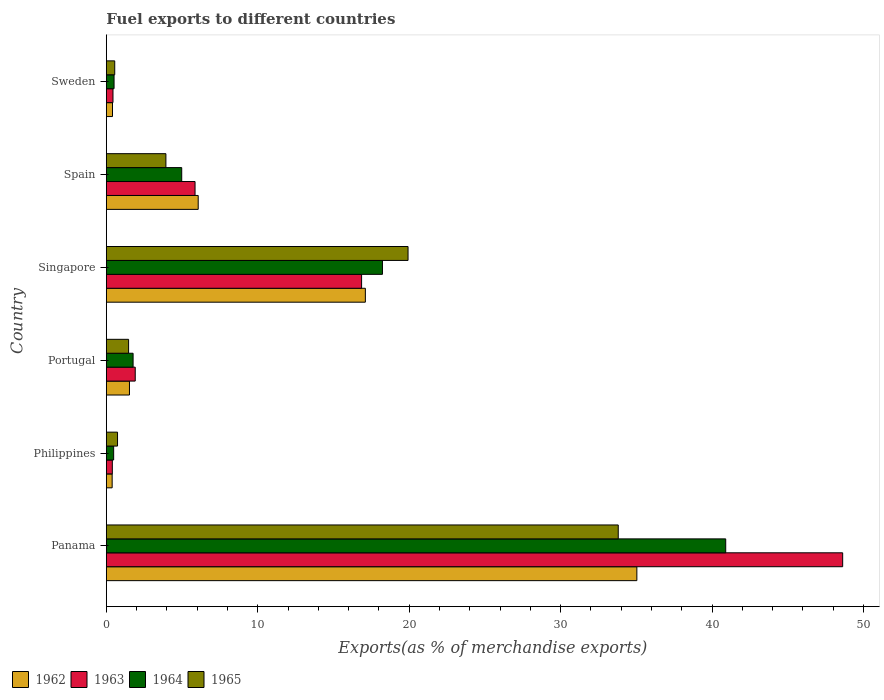Are the number of bars on each tick of the Y-axis equal?
Your response must be concise. Yes. How many bars are there on the 6th tick from the bottom?
Give a very brief answer. 4. What is the label of the 2nd group of bars from the top?
Provide a succinct answer. Spain. In how many cases, is the number of bars for a given country not equal to the number of legend labels?
Give a very brief answer. 0. What is the percentage of exports to different countries in 1965 in Philippines?
Give a very brief answer. 0.74. Across all countries, what is the maximum percentage of exports to different countries in 1965?
Ensure brevity in your answer.  33.8. Across all countries, what is the minimum percentage of exports to different countries in 1963?
Keep it short and to the point. 0.4. In which country was the percentage of exports to different countries in 1962 maximum?
Give a very brief answer. Panama. In which country was the percentage of exports to different countries in 1964 minimum?
Give a very brief answer. Philippines. What is the total percentage of exports to different countries in 1965 in the graph?
Provide a succinct answer. 60.42. What is the difference between the percentage of exports to different countries in 1962 in Spain and that in Sweden?
Your response must be concise. 5.66. What is the difference between the percentage of exports to different countries in 1965 in Portugal and the percentage of exports to different countries in 1964 in Spain?
Give a very brief answer. -3.51. What is the average percentage of exports to different countries in 1963 per country?
Ensure brevity in your answer.  12.35. What is the difference between the percentage of exports to different countries in 1965 and percentage of exports to different countries in 1963 in Sweden?
Provide a succinct answer. 0.12. What is the ratio of the percentage of exports to different countries in 1964 in Panama to that in Sweden?
Your response must be concise. 80.13. Is the percentage of exports to different countries in 1963 in Singapore less than that in Spain?
Your response must be concise. No. Is the difference between the percentage of exports to different countries in 1965 in Philippines and Singapore greater than the difference between the percentage of exports to different countries in 1963 in Philippines and Singapore?
Provide a succinct answer. No. What is the difference between the highest and the second highest percentage of exports to different countries in 1965?
Offer a very short reply. 13.88. What is the difference between the highest and the lowest percentage of exports to different countries in 1965?
Your answer should be very brief. 33.25. In how many countries, is the percentage of exports to different countries in 1963 greater than the average percentage of exports to different countries in 1963 taken over all countries?
Give a very brief answer. 2. Is it the case that in every country, the sum of the percentage of exports to different countries in 1964 and percentage of exports to different countries in 1963 is greater than the sum of percentage of exports to different countries in 1962 and percentage of exports to different countries in 1965?
Provide a short and direct response. No. What does the 4th bar from the bottom in Philippines represents?
Your response must be concise. 1965. How many countries are there in the graph?
Make the answer very short. 6. Are the values on the major ticks of X-axis written in scientific E-notation?
Give a very brief answer. No. Does the graph contain any zero values?
Ensure brevity in your answer.  No. Does the graph contain grids?
Make the answer very short. No. How many legend labels are there?
Give a very brief answer. 4. What is the title of the graph?
Offer a very short reply. Fuel exports to different countries. Does "2006" appear as one of the legend labels in the graph?
Keep it short and to the point. No. What is the label or title of the X-axis?
Make the answer very short. Exports(as % of merchandise exports). What is the label or title of the Y-axis?
Provide a short and direct response. Country. What is the Exports(as % of merchandise exports) of 1962 in Panama?
Your response must be concise. 35.03. What is the Exports(as % of merchandise exports) in 1963 in Panama?
Provide a succinct answer. 48.62. What is the Exports(as % of merchandise exports) in 1964 in Panama?
Make the answer very short. 40.9. What is the Exports(as % of merchandise exports) in 1965 in Panama?
Keep it short and to the point. 33.8. What is the Exports(as % of merchandise exports) in 1962 in Philippines?
Provide a succinct answer. 0.38. What is the Exports(as % of merchandise exports) in 1963 in Philippines?
Make the answer very short. 0.4. What is the Exports(as % of merchandise exports) in 1964 in Philippines?
Keep it short and to the point. 0.48. What is the Exports(as % of merchandise exports) of 1965 in Philippines?
Keep it short and to the point. 0.74. What is the Exports(as % of merchandise exports) of 1962 in Portugal?
Give a very brief answer. 1.53. What is the Exports(as % of merchandise exports) of 1963 in Portugal?
Your answer should be very brief. 1.91. What is the Exports(as % of merchandise exports) of 1964 in Portugal?
Keep it short and to the point. 1.77. What is the Exports(as % of merchandise exports) of 1965 in Portugal?
Ensure brevity in your answer.  1.47. What is the Exports(as % of merchandise exports) of 1962 in Singapore?
Offer a very short reply. 17.1. What is the Exports(as % of merchandise exports) of 1963 in Singapore?
Provide a succinct answer. 16.85. What is the Exports(as % of merchandise exports) in 1964 in Singapore?
Offer a terse response. 18.23. What is the Exports(as % of merchandise exports) in 1965 in Singapore?
Your response must be concise. 19.92. What is the Exports(as % of merchandise exports) of 1962 in Spain?
Provide a succinct answer. 6.07. What is the Exports(as % of merchandise exports) of 1963 in Spain?
Provide a short and direct response. 5.86. What is the Exports(as % of merchandise exports) of 1964 in Spain?
Make the answer very short. 4.98. What is the Exports(as % of merchandise exports) in 1965 in Spain?
Provide a succinct answer. 3.93. What is the Exports(as % of merchandise exports) of 1962 in Sweden?
Ensure brevity in your answer.  0.41. What is the Exports(as % of merchandise exports) in 1963 in Sweden?
Offer a terse response. 0.44. What is the Exports(as % of merchandise exports) of 1964 in Sweden?
Your answer should be very brief. 0.51. What is the Exports(as % of merchandise exports) in 1965 in Sweden?
Your answer should be very brief. 0.55. Across all countries, what is the maximum Exports(as % of merchandise exports) of 1962?
Your answer should be compact. 35.03. Across all countries, what is the maximum Exports(as % of merchandise exports) of 1963?
Provide a succinct answer. 48.62. Across all countries, what is the maximum Exports(as % of merchandise exports) of 1964?
Give a very brief answer. 40.9. Across all countries, what is the maximum Exports(as % of merchandise exports) in 1965?
Your answer should be very brief. 33.8. Across all countries, what is the minimum Exports(as % of merchandise exports) of 1962?
Keep it short and to the point. 0.38. Across all countries, what is the minimum Exports(as % of merchandise exports) in 1963?
Make the answer very short. 0.4. Across all countries, what is the minimum Exports(as % of merchandise exports) in 1964?
Make the answer very short. 0.48. Across all countries, what is the minimum Exports(as % of merchandise exports) of 1965?
Provide a short and direct response. 0.55. What is the total Exports(as % of merchandise exports) of 1962 in the graph?
Make the answer very short. 60.52. What is the total Exports(as % of merchandise exports) in 1963 in the graph?
Ensure brevity in your answer.  74.08. What is the total Exports(as % of merchandise exports) in 1964 in the graph?
Keep it short and to the point. 66.87. What is the total Exports(as % of merchandise exports) of 1965 in the graph?
Your answer should be compact. 60.42. What is the difference between the Exports(as % of merchandise exports) in 1962 in Panama and that in Philippines?
Offer a very short reply. 34.65. What is the difference between the Exports(as % of merchandise exports) of 1963 in Panama and that in Philippines?
Provide a short and direct response. 48.22. What is the difference between the Exports(as % of merchandise exports) of 1964 in Panama and that in Philippines?
Give a very brief answer. 40.41. What is the difference between the Exports(as % of merchandise exports) in 1965 in Panama and that in Philippines?
Offer a very short reply. 33.06. What is the difference between the Exports(as % of merchandise exports) in 1962 in Panama and that in Portugal?
Your answer should be very brief. 33.5. What is the difference between the Exports(as % of merchandise exports) of 1963 in Panama and that in Portugal?
Make the answer very short. 46.71. What is the difference between the Exports(as % of merchandise exports) of 1964 in Panama and that in Portugal?
Your answer should be compact. 39.13. What is the difference between the Exports(as % of merchandise exports) of 1965 in Panama and that in Portugal?
Provide a succinct answer. 32.33. What is the difference between the Exports(as % of merchandise exports) of 1962 in Panama and that in Singapore?
Make the answer very short. 17.93. What is the difference between the Exports(as % of merchandise exports) of 1963 in Panama and that in Singapore?
Give a very brief answer. 31.77. What is the difference between the Exports(as % of merchandise exports) of 1964 in Panama and that in Singapore?
Your answer should be very brief. 22.67. What is the difference between the Exports(as % of merchandise exports) in 1965 in Panama and that in Singapore?
Make the answer very short. 13.88. What is the difference between the Exports(as % of merchandise exports) in 1962 in Panama and that in Spain?
Your response must be concise. 28.96. What is the difference between the Exports(as % of merchandise exports) in 1963 in Panama and that in Spain?
Offer a terse response. 42.76. What is the difference between the Exports(as % of merchandise exports) in 1964 in Panama and that in Spain?
Give a very brief answer. 35.92. What is the difference between the Exports(as % of merchandise exports) in 1965 in Panama and that in Spain?
Your answer should be compact. 29.87. What is the difference between the Exports(as % of merchandise exports) in 1962 in Panama and that in Sweden?
Offer a terse response. 34.62. What is the difference between the Exports(as % of merchandise exports) in 1963 in Panama and that in Sweden?
Your answer should be very brief. 48.18. What is the difference between the Exports(as % of merchandise exports) of 1964 in Panama and that in Sweden?
Keep it short and to the point. 40.39. What is the difference between the Exports(as % of merchandise exports) of 1965 in Panama and that in Sweden?
Provide a short and direct response. 33.25. What is the difference between the Exports(as % of merchandise exports) of 1962 in Philippines and that in Portugal?
Make the answer very short. -1.14. What is the difference between the Exports(as % of merchandise exports) in 1963 in Philippines and that in Portugal?
Your answer should be compact. -1.51. What is the difference between the Exports(as % of merchandise exports) in 1964 in Philippines and that in Portugal?
Provide a succinct answer. -1.28. What is the difference between the Exports(as % of merchandise exports) in 1965 in Philippines and that in Portugal?
Your answer should be very brief. -0.73. What is the difference between the Exports(as % of merchandise exports) in 1962 in Philippines and that in Singapore?
Give a very brief answer. -16.72. What is the difference between the Exports(as % of merchandise exports) of 1963 in Philippines and that in Singapore?
Your answer should be compact. -16.46. What is the difference between the Exports(as % of merchandise exports) of 1964 in Philippines and that in Singapore?
Ensure brevity in your answer.  -17.75. What is the difference between the Exports(as % of merchandise exports) in 1965 in Philippines and that in Singapore?
Offer a very short reply. -19.18. What is the difference between the Exports(as % of merchandise exports) in 1962 in Philippines and that in Spain?
Your response must be concise. -5.68. What is the difference between the Exports(as % of merchandise exports) of 1963 in Philippines and that in Spain?
Offer a terse response. -5.46. What is the difference between the Exports(as % of merchandise exports) of 1964 in Philippines and that in Spain?
Your answer should be compact. -4.49. What is the difference between the Exports(as % of merchandise exports) of 1965 in Philippines and that in Spain?
Your response must be concise. -3.19. What is the difference between the Exports(as % of merchandise exports) of 1962 in Philippines and that in Sweden?
Make the answer very short. -0.02. What is the difference between the Exports(as % of merchandise exports) of 1963 in Philippines and that in Sweden?
Offer a very short reply. -0.04. What is the difference between the Exports(as % of merchandise exports) of 1964 in Philippines and that in Sweden?
Keep it short and to the point. -0.03. What is the difference between the Exports(as % of merchandise exports) of 1965 in Philippines and that in Sweden?
Offer a very short reply. 0.19. What is the difference between the Exports(as % of merchandise exports) in 1962 in Portugal and that in Singapore?
Give a very brief answer. -15.58. What is the difference between the Exports(as % of merchandise exports) of 1963 in Portugal and that in Singapore?
Provide a short and direct response. -14.95. What is the difference between the Exports(as % of merchandise exports) in 1964 in Portugal and that in Singapore?
Offer a terse response. -16.47. What is the difference between the Exports(as % of merchandise exports) of 1965 in Portugal and that in Singapore?
Your answer should be very brief. -18.45. What is the difference between the Exports(as % of merchandise exports) of 1962 in Portugal and that in Spain?
Give a very brief answer. -4.54. What is the difference between the Exports(as % of merchandise exports) in 1963 in Portugal and that in Spain?
Offer a very short reply. -3.95. What is the difference between the Exports(as % of merchandise exports) of 1964 in Portugal and that in Spain?
Offer a very short reply. -3.21. What is the difference between the Exports(as % of merchandise exports) of 1965 in Portugal and that in Spain?
Your answer should be compact. -2.46. What is the difference between the Exports(as % of merchandise exports) in 1962 in Portugal and that in Sweden?
Provide a succinct answer. 1.12. What is the difference between the Exports(as % of merchandise exports) in 1963 in Portugal and that in Sweden?
Ensure brevity in your answer.  1.47. What is the difference between the Exports(as % of merchandise exports) in 1964 in Portugal and that in Sweden?
Offer a very short reply. 1.26. What is the difference between the Exports(as % of merchandise exports) in 1965 in Portugal and that in Sweden?
Give a very brief answer. 0.91. What is the difference between the Exports(as % of merchandise exports) of 1962 in Singapore and that in Spain?
Provide a short and direct response. 11.04. What is the difference between the Exports(as % of merchandise exports) in 1963 in Singapore and that in Spain?
Your response must be concise. 11. What is the difference between the Exports(as % of merchandise exports) in 1964 in Singapore and that in Spain?
Offer a very short reply. 13.25. What is the difference between the Exports(as % of merchandise exports) of 1965 in Singapore and that in Spain?
Offer a very short reply. 15.99. What is the difference between the Exports(as % of merchandise exports) in 1962 in Singapore and that in Sweden?
Give a very brief answer. 16.7. What is the difference between the Exports(as % of merchandise exports) in 1963 in Singapore and that in Sweden?
Provide a short and direct response. 16.42. What is the difference between the Exports(as % of merchandise exports) in 1964 in Singapore and that in Sweden?
Offer a terse response. 17.72. What is the difference between the Exports(as % of merchandise exports) in 1965 in Singapore and that in Sweden?
Keep it short and to the point. 19.37. What is the difference between the Exports(as % of merchandise exports) in 1962 in Spain and that in Sweden?
Ensure brevity in your answer.  5.66. What is the difference between the Exports(as % of merchandise exports) in 1963 in Spain and that in Sweden?
Provide a short and direct response. 5.42. What is the difference between the Exports(as % of merchandise exports) in 1964 in Spain and that in Sweden?
Provide a short and direct response. 4.47. What is the difference between the Exports(as % of merchandise exports) of 1965 in Spain and that in Sweden?
Make the answer very short. 3.38. What is the difference between the Exports(as % of merchandise exports) of 1962 in Panama and the Exports(as % of merchandise exports) of 1963 in Philippines?
Offer a terse response. 34.63. What is the difference between the Exports(as % of merchandise exports) of 1962 in Panama and the Exports(as % of merchandise exports) of 1964 in Philippines?
Your answer should be very brief. 34.55. What is the difference between the Exports(as % of merchandise exports) in 1962 in Panama and the Exports(as % of merchandise exports) in 1965 in Philippines?
Give a very brief answer. 34.29. What is the difference between the Exports(as % of merchandise exports) in 1963 in Panama and the Exports(as % of merchandise exports) in 1964 in Philippines?
Your response must be concise. 48.14. What is the difference between the Exports(as % of merchandise exports) in 1963 in Panama and the Exports(as % of merchandise exports) in 1965 in Philippines?
Provide a succinct answer. 47.88. What is the difference between the Exports(as % of merchandise exports) of 1964 in Panama and the Exports(as % of merchandise exports) of 1965 in Philippines?
Your answer should be compact. 40.16. What is the difference between the Exports(as % of merchandise exports) of 1962 in Panama and the Exports(as % of merchandise exports) of 1963 in Portugal?
Your answer should be very brief. 33.12. What is the difference between the Exports(as % of merchandise exports) in 1962 in Panama and the Exports(as % of merchandise exports) in 1964 in Portugal?
Your response must be concise. 33.26. What is the difference between the Exports(as % of merchandise exports) in 1962 in Panama and the Exports(as % of merchandise exports) in 1965 in Portugal?
Make the answer very short. 33.56. What is the difference between the Exports(as % of merchandise exports) in 1963 in Panama and the Exports(as % of merchandise exports) in 1964 in Portugal?
Your answer should be compact. 46.85. What is the difference between the Exports(as % of merchandise exports) of 1963 in Panama and the Exports(as % of merchandise exports) of 1965 in Portugal?
Give a very brief answer. 47.15. What is the difference between the Exports(as % of merchandise exports) of 1964 in Panama and the Exports(as % of merchandise exports) of 1965 in Portugal?
Your answer should be compact. 39.43. What is the difference between the Exports(as % of merchandise exports) of 1962 in Panama and the Exports(as % of merchandise exports) of 1963 in Singapore?
Make the answer very short. 18.18. What is the difference between the Exports(as % of merchandise exports) in 1962 in Panama and the Exports(as % of merchandise exports) in 1964 in Singapore?
Provide a short and direct response. 16.8. What is the difference between the Exports(as % of merchandise exports) of 1962 in Panama and the Exports(as % of merchandise exports) of 1965 in Singapore?
Your response must be concise. 15.11. What is the difference between the Exports(as % of merchandise exports) of 1963 in Panama and the Exports(as % of merchandise exports) of 1964 in Singapore?
Your answer should be compact. 30.39. What is the difference between the Exports(as % of merchandise exports) of 1963 in Panama and the Exports(as % of merchandise exports) of 1965 in Singapore?
Provide a succinct answer. 28.7. What is the difference between the Exports(as % of merchandise exports) of 1964 in Panama and the Exports(as % of merchandise exports) of 1965 in Singapore?
Provide a short and direct response. 20.98. What is the difference between the Exports(as % of merchandise exports) of 1962 in Panama and the Exports(as % of merchandise exports) of 1963 in Spain?
Keep it short and to the point. 29.17. What is the difference between the Exports(as % of merchandise exports) of 1962 in Panama and the Exports(as % of merchandise exports) of 1964 in Spain?
Your response must be concise. 30.05. What is the difference between the Exports(as % of merchandise exports) in 1962 in Panama and the Exports(as % of merchandise exports) in 1965 in Spain?
Ensure brevity in your answer.  31.1. What is the difference between the Exports(as % of merchandise exports) in 1963 in Panama and the Exports(as % of merchandise exports) in 1964 in Spain?
Make the answer very short. 43.64. What is the difference between the Exports(as % of merchandise exports) of 1963 in Panama and the Exports(as % of merchandise exports) of 1965 in Spain?
Keep it short and to the point. 44.69. What is the difference between the Exports(as % of merchandise exports) of 1964 in Panama and the Exports(as % of merchandise exports) of 1965 in Spain?
Keep it short and to the point. 36.96. What is the difference between the Exports(as % of merchandise exports) of 1962 in Panama and the Exports(as % of merchandise exports) of 1963 in Sweden?
Offer a terse response. 34.59. What is the difference between the Exports(as % of merchandise exports) in 1962 in Panama and the Exports(as % of merchandise exports) in 1964 in Sweden?
Make the answer very short. 34.52. What is the difference between the Exports(as % of merchandise exports) in 1962 in Panama and the Exports(as % of merchandise exports) in 1965 in Sweden?
Your answer should be very brief. 34.48. What is the difference between the Exports(as % of merchandise exports) in 1963 in Panama and the Exports(as % of merchandise exports) in 1964 in Sweden?
Provide a short and direct response. 48.11. What is the difference between the Exports(as % of merchandise exports) in 1963 in Panama and the Exports(as % of merchandise exports) in 1965 in Sweden?
Your response must be concise. 48.07. What is the difference between the Exports(as % of merchandise exports) of 1964 in Panama and the Exports(as % of merchandise exports) of 1965 in Sweden?
Your answer should be very brief. 40.34. What is the difference between the Exports(as % of merchandise exports) of 1962 in Philippines and the Exports(as % of merchandise exports) of 1963 in Portugal?
Your response must be concise. -1.52. What is the difference between the Exports(as % of merchandise exports) in 1962 in Philippines and the Exports(as % of merchandise exports) in 1964 in Portugal?
Your answer should be very brief. -1.38. What is the difference between the Exports(as % of merchandise exports) of 1962 in Philippines and the Exports(as % of merchandise exports) of 1965 in Portugal?
Offer a very short reply. -1.08. What is the difference between the Exports(as % of merchandise exports) of 1963 in Philippines and the Exports(as % of merchandise exports) of 1964 in Portugal?
Ensure brevity in your answer.  -1.37. What is the difference between the Exports(as % of merchandise exports) of 1963 in Philippines and the Exports(as % of merchandise exports) of 1965 in Portugal?
Keep it short and to the point. -1.07. What is the difference between the Exports(as % of merchandise exports) of 1964 in Philippines and the Exports(as % of merchandise exports) of 1965 in Portugal?
Give a very brief answer. -0.99. What is the difference between the Exports(as % of merchandise exports) of 1962 in Philippines and the Exports(as % of merchandise exports) of 1963 in Singapore?
Your answer should be compact. -16.47. What is the difference between the Exports(as % of merchandise exports) in 1962 in Philippines and the Exports(as % of merchandise exports) in 1964 in Singapore?
Make the answer very short. -17.85. What is the difference between the Exports(as % of merchandise exports) of 1962 in Philippines and the Exports(as % of merchandise exports) of 1965 in Singapore?
Provide a succinct answer. -19.54. What is the difference between the Exports(as % of merchandise exports) in 1963 in Philippines and the Exports(as % of merchandise exports) in 1964 in Singapore?
Make the answer very short. -17.84. What is the difference between the Exports(as % of merchandise exports) in 1963 in Philippines and the Exports(as % of merchandise exports) in 1965 in Singapore?
Your answer should be very brief. -19.53. What is the difference between the Exports(as % of merchandise exports) of 1964 in Philippines and the Exports(as % of merchandise exports) of 1965 in Singapore?
Ensure brevity in your answer.  -19.44. What is the difference between the Exports(as % of merchandise exports) of 1962 in Philippines and the Exports(as % of merchandise exports) of 1963 in Spain?
Give a very brief answer. -5.47. What is the difference between the Exports(as % of merchandise exports) in 1962 in Philippines and the Exports(as % of merchandise exports) in 1964 in Spain?
Make the answer very short. -4.59. What is the difference between the Exports(as % of merchandise exports) in 1962 in Philippines and the Exports(as % of merchandise exports) in 1965 in Spain?
Provide a succinct answer. -3.55. What is the difference between the Exports(as % of merchandise exports) in 1963 in Philippines and the Exports(as % of merchandise exports) in 1964 in Spain?
Your answer should be compact. -4.58. What is the difference between the Exports(as % of merchandise exports) of 1963 in Philippines and the Exports(as % of merchandise exports) of 1965 in Spain?
Make the answer very short. -3.54. What is the difference between the Exports(as % of merchandise exports) of 1964 in Philippines and the Exports(as % of merchandise exports) of 1965 in Spain?
Provide a short and direct response. -3.45. What is the difference between the Exports(as % of merchandise exports) in 1962 in Philippines and the Exports(as % of merchandise exports) in 1963 in Sweden?
Offer a very short reply. -0.05. What is the difference between the Exports(as % of merchandise exports) of 1962 in Philippines and the Exports(as % of merchandise exports) of 1964 in Sweden?
Offer a very short reply. -0.13. What is the difference between the Exports(as % of merchandise exports) in 1962 in Philippines and the Exports(as % of merchandise exports) in 1965 in Sweden?
Your answer should be very brief. -0.17. What is the difference between the Exports(as % of merchandise exports) in 1963 in Philippines and the Exports(as % of merchandise exports) in 1964 in Sweden?
Offer a very short reply. -0.11. What is the difference between the Exports(as % of merchandise exports) in 1963 in Philippines and the Exports(as % of merchandise exports) in 1965 in Sweden?
Keep it short and to the point. -0.16. What is the difference between the Exports(as % of merchandise exports) of 1964 in Philippines and the Exports(as % of merchandise exports) of 1965 in Sweden?
Offer a very short reply. -0.07. What is the difference between the Exports(as % of merchandise exports) of 1962 in Portugal and the Exports(as % of merchandise exports) of 1963 in Singapore?
Provide a short and direct response. -15.33. What is the difference between the Exports(as % of merchandise exports) in 1962 in Portugal and the Exports(as % of merchandise exports) in 1964 in Singapore?
Provide a succinct answer. -16.7. What is the difference between the Exports(as % of merchandise exports) in 1962 in Portugal and the Exports(as % of merchandise exports) in 1965 in Singapore?
Your answer should be very brief. -18.39. What is the difference between the Exports(as % of merchandise exports) of 1963 in Portugal and the Exports(as % of merchandise exports) of 1964 in Singapore?
Offer a very short reply. -16.32. What is the difference between the Exports(as % of merchandise exports) in 1963 in Portugal and the Exports(as % of merchandise exports) in 1965 in Singapore?
Provide a succinct answer. -18.01. What is the difference between the Exports(as % of merchandise exports) in 1964 in Portugal and the Exports(as % of merchandise exports) in 1965 in Singapore?
Give a very brief answer. -18.16. What is the difference between the Exports(as % of merchandise exports) of 1962 in Portugal and the Exports(as % of merchandise exports) of 1963 in Spain?
Your response must be concise. -4.33. What is the difference between the Exports(as % of merchandise exports) of 1962 in Portugal and the Exports(as % of merchandise exports) of 1964 in Spain?
Provide a succinct answer. -3.45. What is the difference between the Exports(as % of merchandise exports) of 1962 in Portugal and the Exports(as % of merchandise exports) of 1965 in Spain?
Offer a terse response. -2.41. What is the difference between the Exports(as % of merchandise exports) in 1963 in Portugal and the Exports(as % of merchandise exports) in 1964 in Spain?
Your answer should be very brief. -3.07. What is the difference between the Exports(as % of merchandise exports) of 1963 in Portugal and the Exports(as % of merchandise exports) of 1965 in Spain?
Your response must be concise. -2.03. What is the difference between the Exports(as % of merchandise exports) of 1964 in Portugal and the Exports(as % of merchandise exports) of 1965 in Spain?
Offer a terse response. -2.17. What is the difference between the Exports(as % of merchandise exports) of 1962 in Portugal and the Exports(as % of merchandise exports) of 1963 in Sweden?
Make the answer very short. 1.09. What is the difference between the Exports(as % of merchandise exports) in 1962 in Portugal and the Exports(as % of merchandise exports) in 1964 in Sweden?
Your answer should be very brief. 1.02. What is the difference between the Exports(as % of merchandise exports) of 1962 in Portugal and the Exports(as % of merchandise exports) of 1965 in Sweden?
Provide a short and direct response. 0.97. What is the difference between the Exports(as % of merchandise exports) in 1963 in Portugal and the Exports(as % of merchandise exports) in 1964 in Sweden?
Give a very brief answer. 1.4. What is the difference between the Exports(as % of merchandise exports) of 1963 in Portugal and the Exports(as % of merchandise exports) of 1965 in Sweden?
Ensure brevity in your answer.  1.35. What is the difference between the Exports(as % of merchandise exports) in 1964 in Portugal and the Exports(as % of merchandise exports) in 1965 in Sweden?
Provide a succinct answer. 1.21. What is the difference between the Exports(as % of merchandise exports) of 1962 in Singapore and the Exports(as % of merchandise exports) of 1963 in Spain?
Provide a succinct answer. 11.25. What is the difference between the Exports(as % of merchandise exports) of 1962 in Singapore and the Exports(as % of merchandise exports) of 1964 in Spain?
Your answer should be compact. 12.13. What is the difference between the Exports(as % of merchandise exports) of 1962 in Singapore and the Exports(as % of merchandise exports) of 1965 in Spain?
Provide a short and direct response. 13.17. What is the difference between the Exports(as % of merchandise exports) in 1963 in Singapore and the Exports(as % of merchandise exports) in 1964 in Spain?
Provide a short and direct response. 11.88. What is the difference between the Exports(as % of merchandise exports) in 1963 in Singapore and the Exports(as % of merchandise exports) in 1965 in Spain?
Make the answer very short. 12.92. What is the difference between the Exports(as % of merchandise exports) in 1964 in Singapore and the Exports(as % of merchandise exports) in 1965 in Spain?
Your answer should be very brief. 14.3. What is the difference between the Exports(as % of merchandise exports) of 1962 in Singapore and the Exports(as % of merchandise exports) of 1963 in Sweden?
Keep it short and to the point. 16.66. What is the difference between the Exports(as % of merchandise exports) of 1962 in Singapore and the Exports(as % of merchandise exports) of 1964 in Sweden?
Keep it short and to the point. 16.59. What is the difference between the Exports(as % of merchandise exports) in 1962 in Singapore and the Exports(as % of merchandise exports) in 1965 in Sweden?
Provide a short and direct response. 16.55. What is the difference between the Exports(as % of merchandise exports) of 1963 in Singapore and the Exports(as % of merchandise exports) of 1964 in Sweden?
Provide a succinct answer. 16.34. What is the difference between the Exports(as % of merchandise exports) in 1963 in Singapore and the Exports(as % of merchandise exports) in 1965 in Sweden?
Give a very brief answer. 16.3. What is the difference between the Exports(as % of merchandise exports) of 1964 in Singapore and the Exports(as % of merchandise exports) of 1965 in Sweden?
Provide a short and direct response. 17.68. What is the difference between the Exports(as % of merchandise exports) in 1962 in Spain and the Exports(as % of merchandise exports) in 1963 in Sweden?
Your response must be concise. 5.63. What is the difference between the Exports(as % of merchandise exports) in 1962 in Spain and the Exports(as % of merchandise exports) in 1964 in Sweden?
Keep it short and to the point. 5.56. What is the difference between the Exports(as % of merchandise exports) in 1962 in Spain and the Exports(as % of merchandise exports) in 1965 in Sweden?
Your answer should be very brief. 5.51. What is the difference between the Exports(as % of merchandise exports) of 1963 in Spain and the Exports(as % of merchandise exports) of 1964 in Sweden?
Give a very brief answer. 5.35. What is the difference between the Exports(as % of merchandise exports) of 1963 in Spain and the Exports(as % of merchandise exports) of 1965 in Sweden?
Keep it short and to the point. 5.3. What is the difference between the Exports(as % of merchandise exports) of 1964 in Spain and the Exports(as % of merchandise exports) of 1965 in Sweden?
Offer a very short reply. 4.42. What is the average Exports(as % of merchandise exports) in 1962 per country?
Your answer should be very brief. 10.09. What is the average Exports(as % of merchandise exports) in 1963 per country?
Keep it short and to the point. 12.35. What is the average Exports(as % of merchandise exports) in 1964 per country?
Make the answer very short. 11.14. What is the average Exports(as % of merchandise exports) in 1965 per country?
Provide a short and direct response. 10.07. What is the difference between the Exports(as % of merchandise exports) in 1962 and Exports(as % of merchandise exports) in 1963 in Panama?
Offer a terse response. -13.59. What is the difference between the Exports(as % of merchandise exports) in 1962 and Exports(as % of merchandise exports) in 1964 in Panama?
Give a very brief answer. -5.87. What is the difference between the Exports(as % of merchandise exports) in 1962 and Exports(as % of merchandise exports) in 1965 in Panama?
Offer a very short reply. 1.23. What is the difference between the Exports(as % of merchandise exports) in 1963 and Exports(as % of merchandise exports) in 1964 in Panama?
Keep it short and to the point. 7.72. What is the difference between the Exports(as % of merchandise exports) in 1963 and Exports(as % of merchandise exports) in 1965 in Panama?
Keep it short and to the point. 14.82. What is the difference between the Exports(as % of merchandise exports) of 1964 and Exports(as % of merchandise exports) of 1965 in Panama?
Your answer should be compact. 7.1. What is the difference between the Exports(as % of merchandise exports) in 1962 and Exports(as % of merchandise exports) in 1963 in Philippines?
Offer a very short reply. -0.01. What is the difference between the Exports(as % of merchandise exports) of 1962 and Exports(as % of merchandise exports) of 1964 in Philippines?
Your response must be concise. -0.1. What is the difference between the Exports(as % of merchandise exports) in 1962 and Exports(as % of merchandise exports) in 1965 in Philippines?
Offer a very short reply. -0.35. What is the difference between the Exports(as % of merchandise exports) of 1963 and Exports(as % of merchandise exports) of 1964 in Philippines?
Keep it short and to the point. -0.09. What is the difference between the Exports(as % of merchandise exports) of 1963 and Exports(as % of merchandise exports) of 1965 in Philippines?
Your response must be concise. -0.34. What is the difference between the Exports(as % of merchandise exports) of 1964 and Exports(as % of merchandise exports) of 1965 in Philippines?
Ensure brevity in your answer.  -0.26. What is the difference between the Exports(as % of merchandise exports) in 1962 and Exports(as % of merchandise exports) in 1963 in Portugal?
Your answer should be compact. -0.38. What is the difference between the Exports(as % of merchandise exports) of 1962 and Exports(as % of merchandise exports) of 1964 in Portugal?
Offer a terse response. -0.24. What is the difference between the Exports(as % of merchandise exports) in 1962 and Exports(as % of merchandise exports) in 1965 in Portugal?
Offer a very short reply. 0.06. What is the difference between the Exports(as % of merchandise exports) of 1963 and Exports(as % of merchandise exports) of 1964 in Portugal?
Your answer should be compact. 0.14. What is the difference between the Exports(as % of merchandise exports) of 1963 and Exports(as % of merchandise exports) of 1965 in Portugal?
Your answer should be very brief. 0.44. What is the difference between the Exports(as % of merchandise exports) of 1964 and Exports(as % of merchandise exports) of 1965 in Portugal?
Make the answer very short. 0.3. What is the difference between the Exports(as % of merchandise exports) in 1962 and Exports(as % of merchandise exports) in 1963 in Singapore?
Keep it short and to the point. 0.25. What is the difference between the Exports(as % of merchandise exports) in 1962 and Exports(as % of merchandise exports) in 1964 in Singapore?
Provide a short and direct response. -1.13. What is the difference between the Exports(as % of merchandise exports) in 1962 and Exports(as % of merchandise exports) in 1965 in Singapore?
Your response must be concise. -2.82. What is the difference between the Exports(as % of merchandise exports) of 1963 and Exports(as % of merchandise exports) of 1964 in Singapore?
Your response must be concise. -1.38. What is the difference between the Exports(as % of merchandise exports) of 1963 and Exports(as % of merchandise exports) of 1965 in Singapore?
Provide a short and direct response. -3.07. What is the difference between the Exports(as % of merchandise exports) in 1964 and Exports(as % of merchandise exports) in 1965 in Singapore?
Keep it short and to the point. -1.69. What is the difference between the Exports(as % of merchandise exports) of 1962 and Exports(as % of merchandise exports) of 1963 in Spain?
Provide a short and direct response. 0.21. What is the difference between the Exports(as % of merchandise exports) of 1962 and Exports(as % of merchandise exports) of 1964 in Spain?
Ensure brevity in your answer.  1.09. What is the difference between the Exports(as % of merchandise exports) in 1962 and Exports(as % of merchandise exports) in 1965 in Spain?
Ensure brevity in your answer.  2.13. What is the difference between the Exports(as % of merchandise exports) in 1963 and Exports(as % of merchandise exports) in 1964 in Spain?
Ensure brevity in your answer.  0.88. What is the difference between the Exports(as % of merchandise exports) in 1963 and Exports(as % of merchandise exports) in 1965 in Spain?
Provide a short and direct response. 1.92. What is the difference between the Exports(as % of merchandise exports) in 1964 and Exports(as % of merchandise exports) in 1965 in Spain?
Provide a succinct answer. 1.04. What is the difference between the Exports(as % of merchandise exports) of 1962 and Exports(as % of merchandise exports) of 1963 in Sweden?
Offer a terse response. -0.03. What is the difference between the Exports(as % of merchandise exports) in 1962 and Exports(as % of merchandise exports) in 1964 in Sweden?
Ensure brevity in your answer.  -0.1. What is the difference between the Exports(as % of merchandise exports) of 1962 and Exports(as % of merchandise exports) of 1965 in Sweden?
Your response must be concise. -0.15. What is the difference between the Exports(as % of merchandise exports) of 1963 and Exports(as % of merchandise exports) of 1964 in Sweden?
Keep it short and to the point. -0.07. What is the difference between the Exports(as % of merchandise exports) of 1963 and Exports(as % of merchandise exports) of 1965 in Sweden?
Your response must be concise. -0.12. What is the difference between the Exports(as % of merchandise exports) in 1964 and Exports(as % of merchandise exports) in 1965 in Sweden?
Your answer should be compact. -0.04. What is the ratio of the Exports(as % of merchandise exports) in 1962 in Panama to that in Philippines?
Keep it short and to the point. 91.01. What is the ratio of the Exports(as % of merchandise exports) of 1963 in Panama to that in Philippines?
Provide a short and direct response. 122.82. What is the ratio of the Exports(as % of merchandise exports) of 1964 in Panama to that in Philippines?
Keep it short and to the point. 84.6. What is the ratio of the Exports(as % of merchandise exports) of 1965 in Panama to that in Philippines?
Give a very brief answer. 45.69. What is the ratio of the Exports(as % of merchandise exports) of 1962 in Panama to that in Portugal?
Keep it short and to the point. 22.92. What is the ratio of the Exports(as % of merchandise exports) of 1963 in Panama to that in Portugal?
Provide a succinct answer. 25.47. What is the ratio of the Exports(as % of merchandise exports) in 1964 in Panama to that in Portugal?
Offer a terse response. 23.15. What is the ratio of the Exports(as % of merchandise exports) of 1965 in Panama to that in Portugal?
Provide a short and direct response. 23. What is the ratio of the Exports(as % of merchandise exports) of 1962 in Panama to that in Singapore?
Offer a terse response. 2.05. What is the ratio of the Exports(as % of merchandise exports) of 1963 in Panama to that in Singapore?
Your answer should be very brief. 2.88. What is the ratio of the Exports(as % of merchandise exports) in 1964 in Panama to that in Singapore?
Make the answer very short. 2.24. What is the ratio of the Exports(as % of merchandise exports) in 1965 in Panama to that in Singapore?
Your answer should be very brief. 1.7. What is the ratio of the Exports(as % of merchandise exports) in 1962 in Panama to that in Spain?
Give a very brief answer. 5.77. What is the ratio of the Exports(as % of merchandise exports) of 1963 in Panama to that in Spain?
Your answer should be very brief. 8.3. What is the ratio of the Exports(as % of merchandise exports) of 1964 in Panama to that in Spain?
Ensure brevity in your answer.  8.22. What is the ratio of the Exports(as % of merchandise exports) in 1965 in Panama to that in Spain?
Give a very brief answer. 8.59. What is the ratio of the Exports(as % of merchandise exports) of 1962 in Panama to that in Sweden?
Provide a short and direct response. 86. What is the ratio of the Exports(as % of merchandise exports) of 1963 in Panama to that in Sweden?
Offer a very short reply. 110.64. What is the ratio of the Exports(as % of merchandise exports) of 1964 in Panama to that in Sweden?
Provide a short and direct response. 80.13. What is the ratio of the Exports(as % of merchandise exports) of 1965 in Panama to that in Sweden?
Your response must be concise. 60.94. What is the ratio of the Exports(as % of merchandise exports) of 1962 in Philippines to that in Portugal?
Provide a short and direct response. 0.25. What is the ratio of the Exports(as % of merchandise exports) in 1963 in Philippines to that in Portugal?
Make the answer very short. 0.21. What is the ratio of the Exports(as % of merchandise exports) in 1964 in Philippines to that in Portugal?
Provide a short and direct response. 0.27. What is the ratio of the Exports(as % of merchandise exports) in 1965 in Philippines to that in Portugal?
Your answer should be compact. 0.5. What is the ratio of the Exports(as % of merchandise exports) in 1962 in Philippines to that in Singapore?
Your answer should be very brief. 0.02. What is the ratio of the Exports(as % of merchandise exports) of 1963 in Philippines to that in Singapore?
Make the answer very short. 0.02. What is the ratio of the Exports(as % of merchandise exports) of 1964 in Philippines to that in Singapore?
Give a very brief answer. 0.03. What is the ratio of the Exports(as % of merchandise exports) of 1965 in Philippines to that in Singapore?
Offer a very short reply. 0.04. What is the ratio of the Exports(as % of merchandise exports) of 1962 in Philippines to that in Spain?
Your answer should be compact. 0.06. What is the ratio of the Exports(as % of merchandise exports) of 1963 in Philippines to that in Spain?
Give a very brief answer. 0.07. What is the ratio of the Exports(as % of merchandise exports) of 1964 in Philippines to that in Spain?
Make the answer very short. 0.1. What is the ratio of the Exports(as % of merchandise exports) in 1965 in Philippines to that in Spain?
Make the answer very short. 0.19. What is the ratio of the Exports(as % of merchandise exports) in 1962 in Philippines to that in Sweden?
Give a very brief answer. 0.94. What is the ratio of the Exports(as % of merchandise exports) of 1963 in Philippines to that in Sweden?
Offer a terse response. 0.9. What is the ratio of the Exports(as % of merchandise exports) of 1964 in Philippines to that in Sweden?
Give a very brief answer. 0.95. What is the ratio of the Exports(as % of merchandise exports) in 1965 in Philippines to that in Sweden?
Your response must be concise. 1.33. What is the ratio of the Exports(as % of merchandise exports) in 1962 in Portugal to that in Singapore?
Offer a very short reply. 0.09. What is the ratio of the Exports(as % of merchandise exports) in 1963 in Portugal to that in Singapore?
Offer a terse response. 0.11. What is the ratio of the Exports(as % of merchandise exports) in 1964 in Portugal to that in Singapore?
Ensure brevity in your answer.  0.1. What is the ratio of the Exports(as % of merchandise exports) in 1965 in Portugal to that in Singapore?
Give a very brief answer. 0.07. What is the ratio of the Exports(as % of merchandise exports) of 1962 in Portugal to that in Spain?
Your answer should be very brief. 0.25. What is the ratio of the Exports(as % of merchandise exports) of 1963 in Portugal to that in Spain?
Provide a succinct answer. 0.33. What is the ratio of the Exports(as % of merchandise exports) in 1964 in Portugal to that in Spain?
Offer a very short reply. 0.35. What is the ratio of the Exports(as % of merchandise exports) of 1965 in Portugal to that in Spain?
Provide a succinct answer. 0.37. What is the ratio of the Exports(as % of merchandise exports) in 1962 in Portugal to that in Sweden?
Provide a succinct answer. 3.75. What is the ratio of the Exports(as % of merchandise exports) of 1963 in Portugal to that in Sweden?
Your response must be concise. 4.34. What is the ratio of the Exports(as % of merchandise exports) of 1964 in Portugal to that in Sweden?
Provide a succinct answer. 3.46. What is the ratio of the Exports(as % of merchandise exports) in 1965 in Portugal to that in Sweden?
Your answer should be very brief. 2.65. What is the ratio of the Exports(as % of merchandise exports) of 1962 in Singapore to that in Spain?
Provide a short and direct response. 2.82. What is the ratio of the Exports(as % of merchandise exports) of 1963 in Singapore to that in Spain?
Offer a terse response. 2.88. What is the ratio of the Exports(as % of merchandise exports) in 1964 in Singapore to that in Spain?
Offer a terse response. 3.66. What is the ratio of the Exports(as % of merchandise exports) of 1965 in Singapore to that in Spain?
Provide a succinct answer. 5.06. What is the ratio of the Exports(as % of merchandise exports) in 1962 in Singapore to that in Sweden?
Your answer should be compact. 41.99. What is the ratio of the Exports(as % of merchandise exports) in 1963 in Singapore to that in Sweden?
Provide a short and direct response. 38.35. What is the ratio of the Exports(as % of merchandise exports) of 1964 in Singapore to that in Sweden?
Offer a terse response. 35.72. What is the ratio of the Exports(as % of merchandise exports) in 1965 in Singapore to that in Sweden?
Ensure brevity in your answer.  35.92. What is the ratio of the Exports(as % of merchandise exports) of 1962 in Spain to that in Sweden?
Keep it short and to the point. 14.89. What is the ratio of the Exports(as % of merchandise exports) of 1963 in Spain to that in Sweden?
Make the answer very short. 13.33. What is the ratio of the Exports(as % of merchandise exports) in 1964 in Spain to that in Sweden?
Your answer should be very brief. 9.75. What is the ratio of the Exports(as % of merchandise exports) in 1965 in Spain to that in Sweden?
Your answer should be compact. 7.09. What is the difference between the highest and the second highest Exports(as % of merchandise exports) in 1962?
Give a very brief answer. 17.93. What is the difference between the highest and the second highest Exports(as % of merchandise exports) in 1963?
Your answer should be very brief. 31.77. What is the difference between the highest and the second highest Exports(as % of merchandise exports) in 1964?
Your answer should be compact. 22.67. What is the difference between the highest and the second highest Exports(as % of merchandise exports) of 1965?
Offer a very short reply. 13.88. What is the difference between the highest and the lowest Exports(as % of merchandise exports) of 1962?
Ensure brevity in your answer.  34.65. What is the difference between the highest and the lowest Exports(as % of merchandise exports) in 1963?
Your response must be concise. 48.22. What is the difference between the highest and the lowest Exports(as % of merchandise exports) in 1964?
Offer a very short reply. 40.41. What is the difference between the highest and the lowest Exports(as % of merchandise exports) in 1965?
Your answer should be compact. 33.25. 